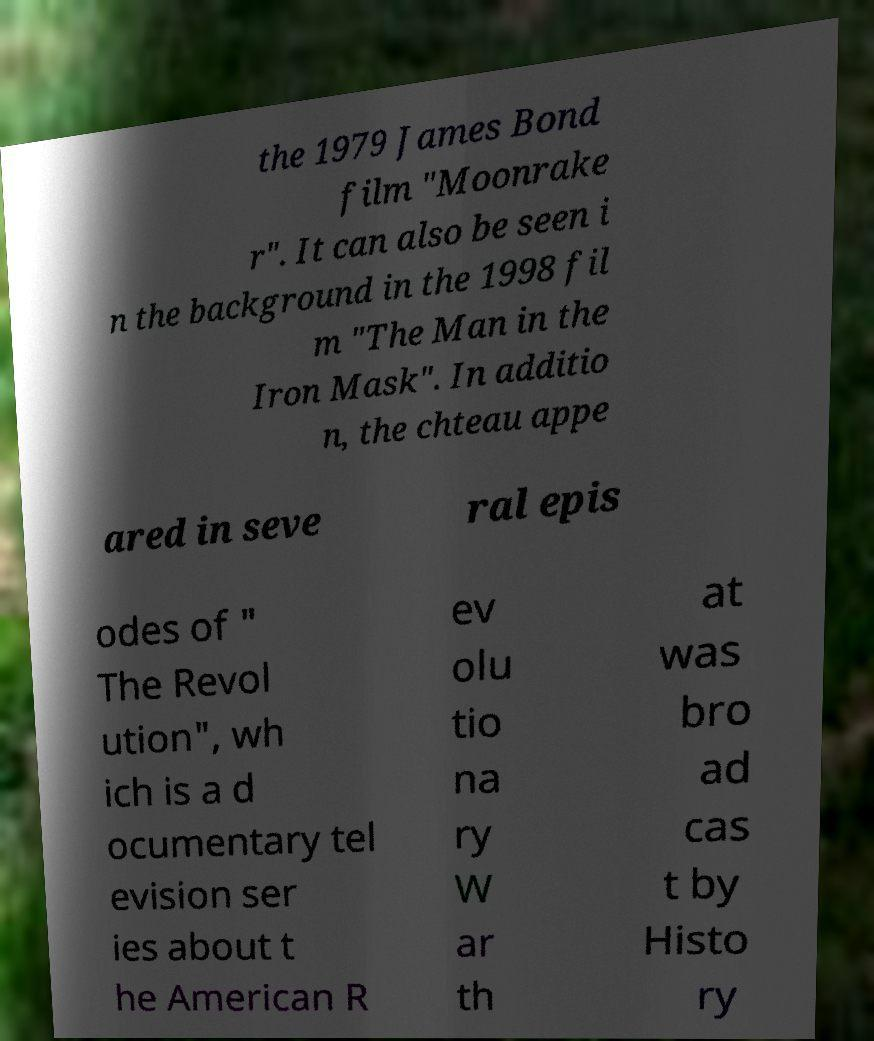Could you extract and type out the text from this image? the 1979 James Bond film "Moonrake r". It can also be seen i n the background in the 1998 fil m "The Man in the Iron Mask". In additio n, the chteau appe ared in seve ral epis odes of " The Revol ution", wh ich is a d ocumentary tel evision ser ies about t he American R ev olu tio na ry W ar th at was bro ad cas t by Histo ry 